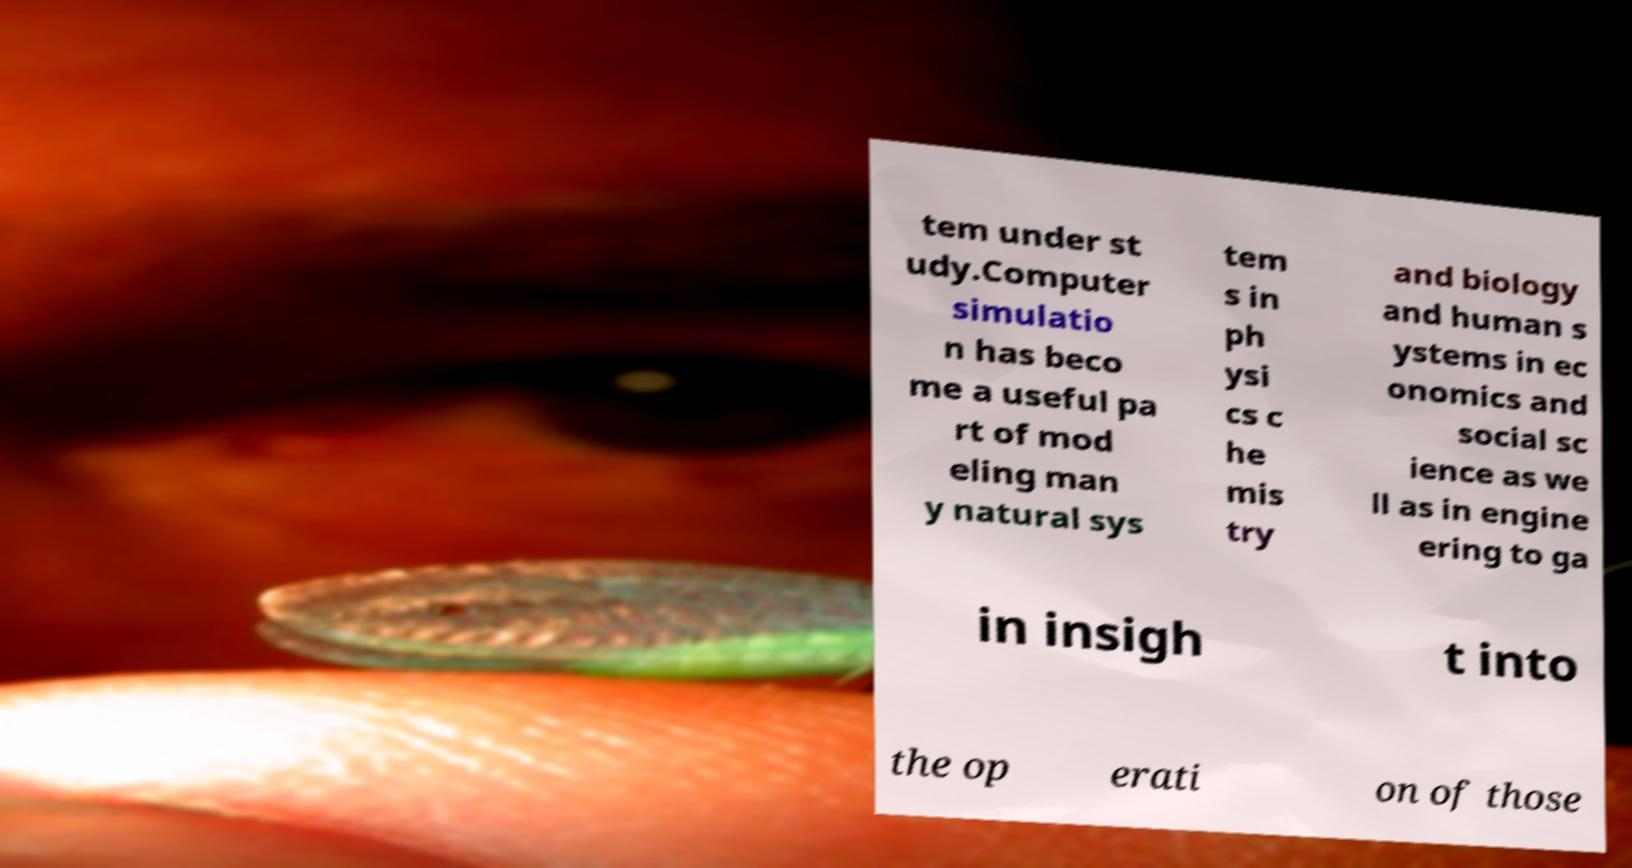Can you accurately transcribe the text from the provided image for me? tem under st udy.Computer simulatio n has beco me a useful pa rt of mod eling man y natural sys tem s in ph ysi cs c he mis try and biology and human s ystems in ec onomics and social sc ience as we ll as in engine ering to ga in insigh t into the op erati on of those 